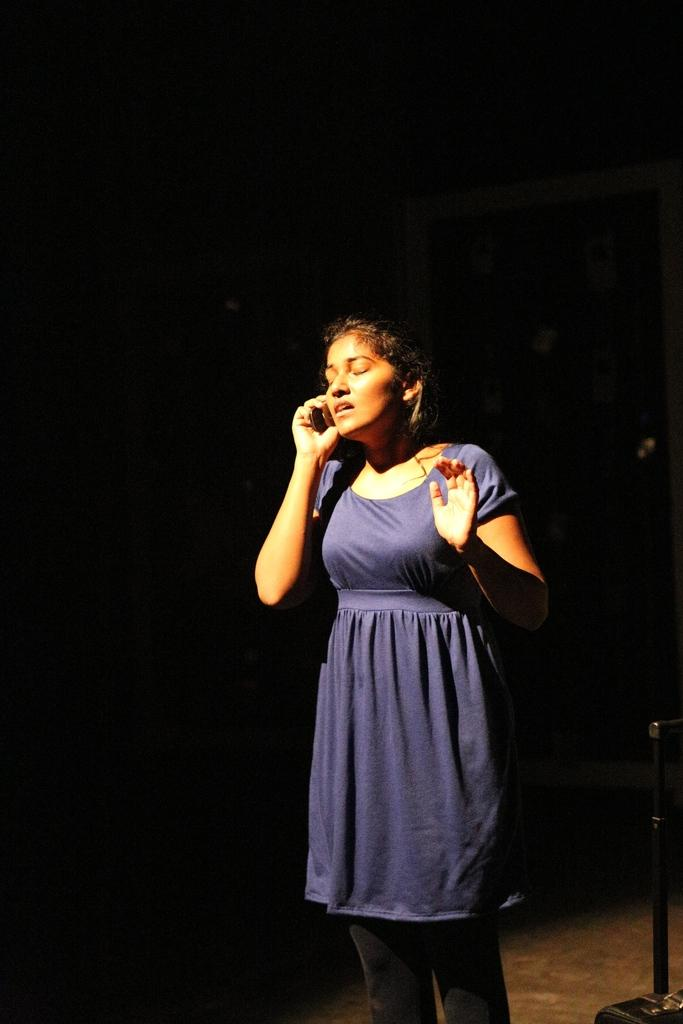What can be seen in the image? There is a person in the image. What is the person doing in the image? The person is standing on the floor. What is the person holding in the image? The person is holding an object. What else can be seen near the person in the image? There is an object beside the person. How would you describe the background of the image? The background of the image is dark. What type of jam is being spread on the person's toast in the image? There is no toast or jam present in the image. 